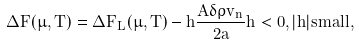<formula> <loc_0><loc_0><loc_500><loc_500>\Delta F ( \mu , T ) = \Delta F _ { L } ( \mu , T ) - h \frac { A \delta \rho v _ { n } } { 2 a } h < 0 , | h | s m a l l ,</formula> 